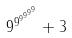<formula> <loc_0><loc_0><loc_500><loc_500>9 ^ { 9 ^ { 9 ^ { 9 ^ { 9 ^ { 9 } } } } } + 3</formula> 